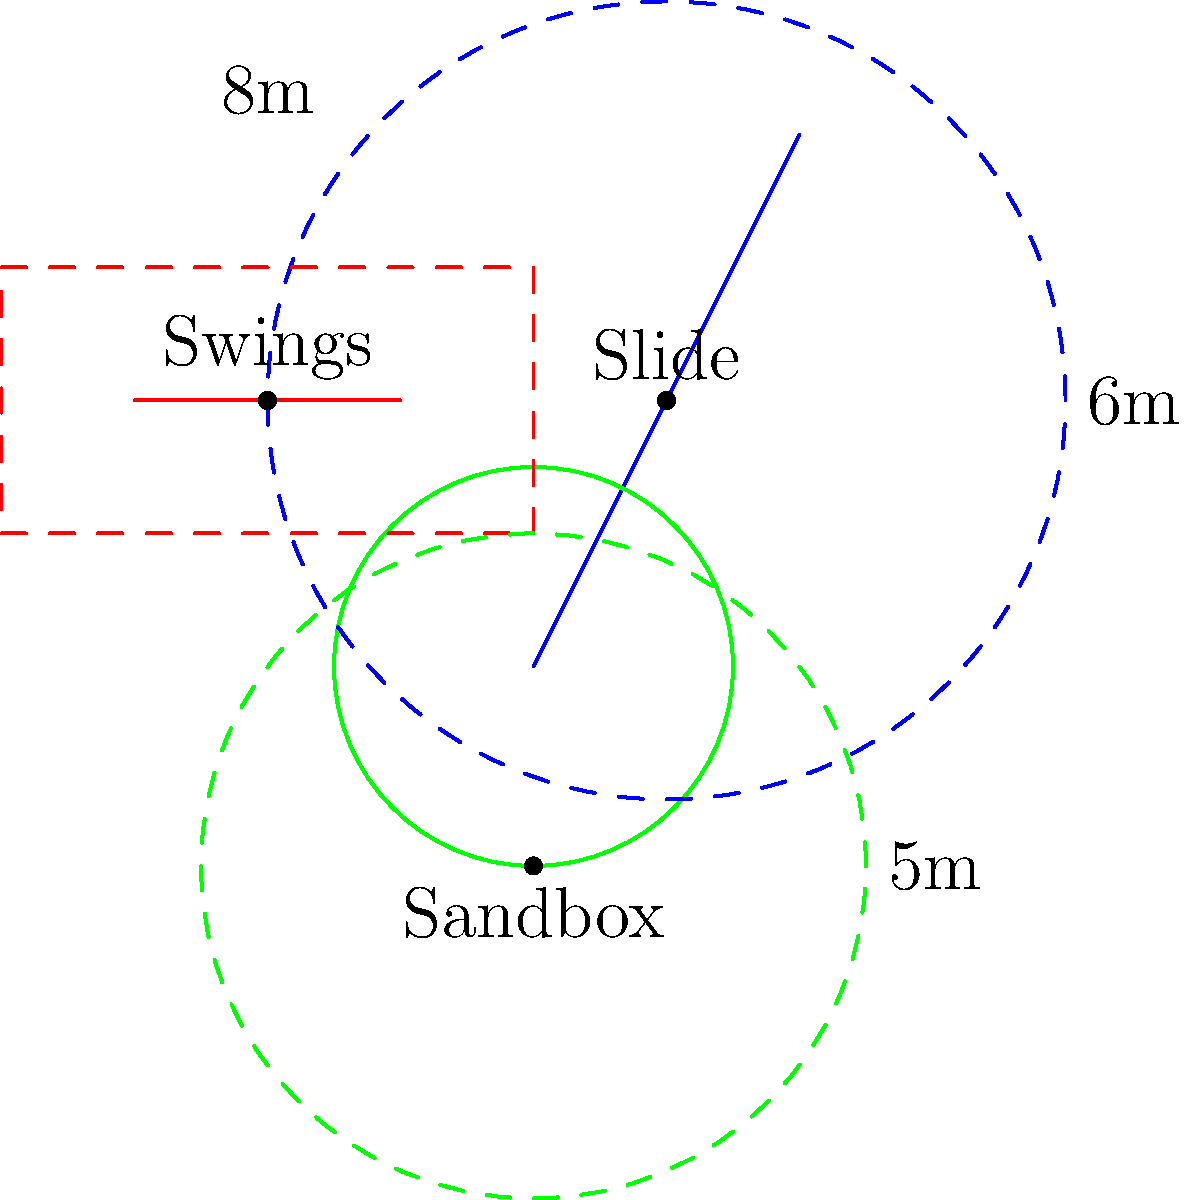In the playground layout shown, safety zones are indicated by dashed lines around each piece of equipment. What is the total area of all safety zones combined, assuming the slide's safety zone is circular and centered at the midpoint of the slide? To calculate the total area of all safety zones, we need to determine the area of each zone and sum them up:

1. Slide safety zone:
   - It's a circle with a radius of 6m
   - Area = $\pi r^2 = \pi (6m)^2 = 36\pi m^2$

2. Swings safety zone:
   - It's a rectangle with dimensions 8m x 4m
   - Area = length * width = 8m * 4m = 32 $m^2$

3. Sandbox safety zone:
   - It's a circle with a radius of 5m
   - Area = $\pi r^2 = \pi (5m)^2 = 25\pi m^2$

Total area:
$$ \text{Total Area} = 36\pi m^2 + 32 m^2 + 25\pi m^2 $$
$$ = 61\pi m^2 + 32 m^2 $$
$$ \approx 223.45 m^2 $$
Answer: $61\pi + 32 \approx 223.45 m^2$ 